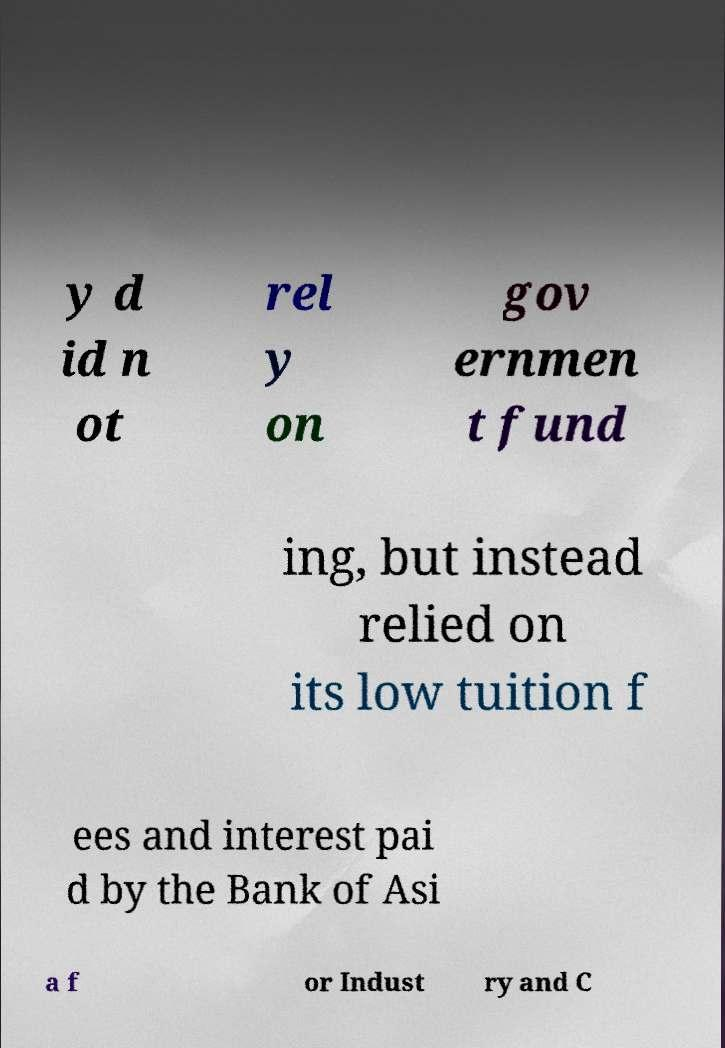What messages or text are displayed in this image? I need them in a readable, typed format. y d id n ot rel y on gov ernmen t fund ing, but instead relied on its low tuition f ees and interest pai d by the Bank of Asi a f or Indust ry and C 